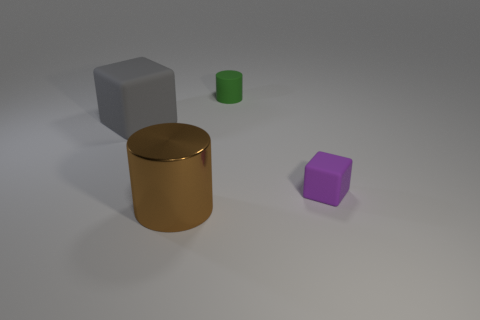Add 2 brown objects. How many objects exist? 6 Add 1 brown objects. How many brown objects are left? 2 Add 1 big rubber things. How many big rubber things exist? 2 Subtract 0 blue cylinders. How many objects are left? 4 Subtract all large rubber cubes. Subtract all tiny objects. How many objects are left? 1 